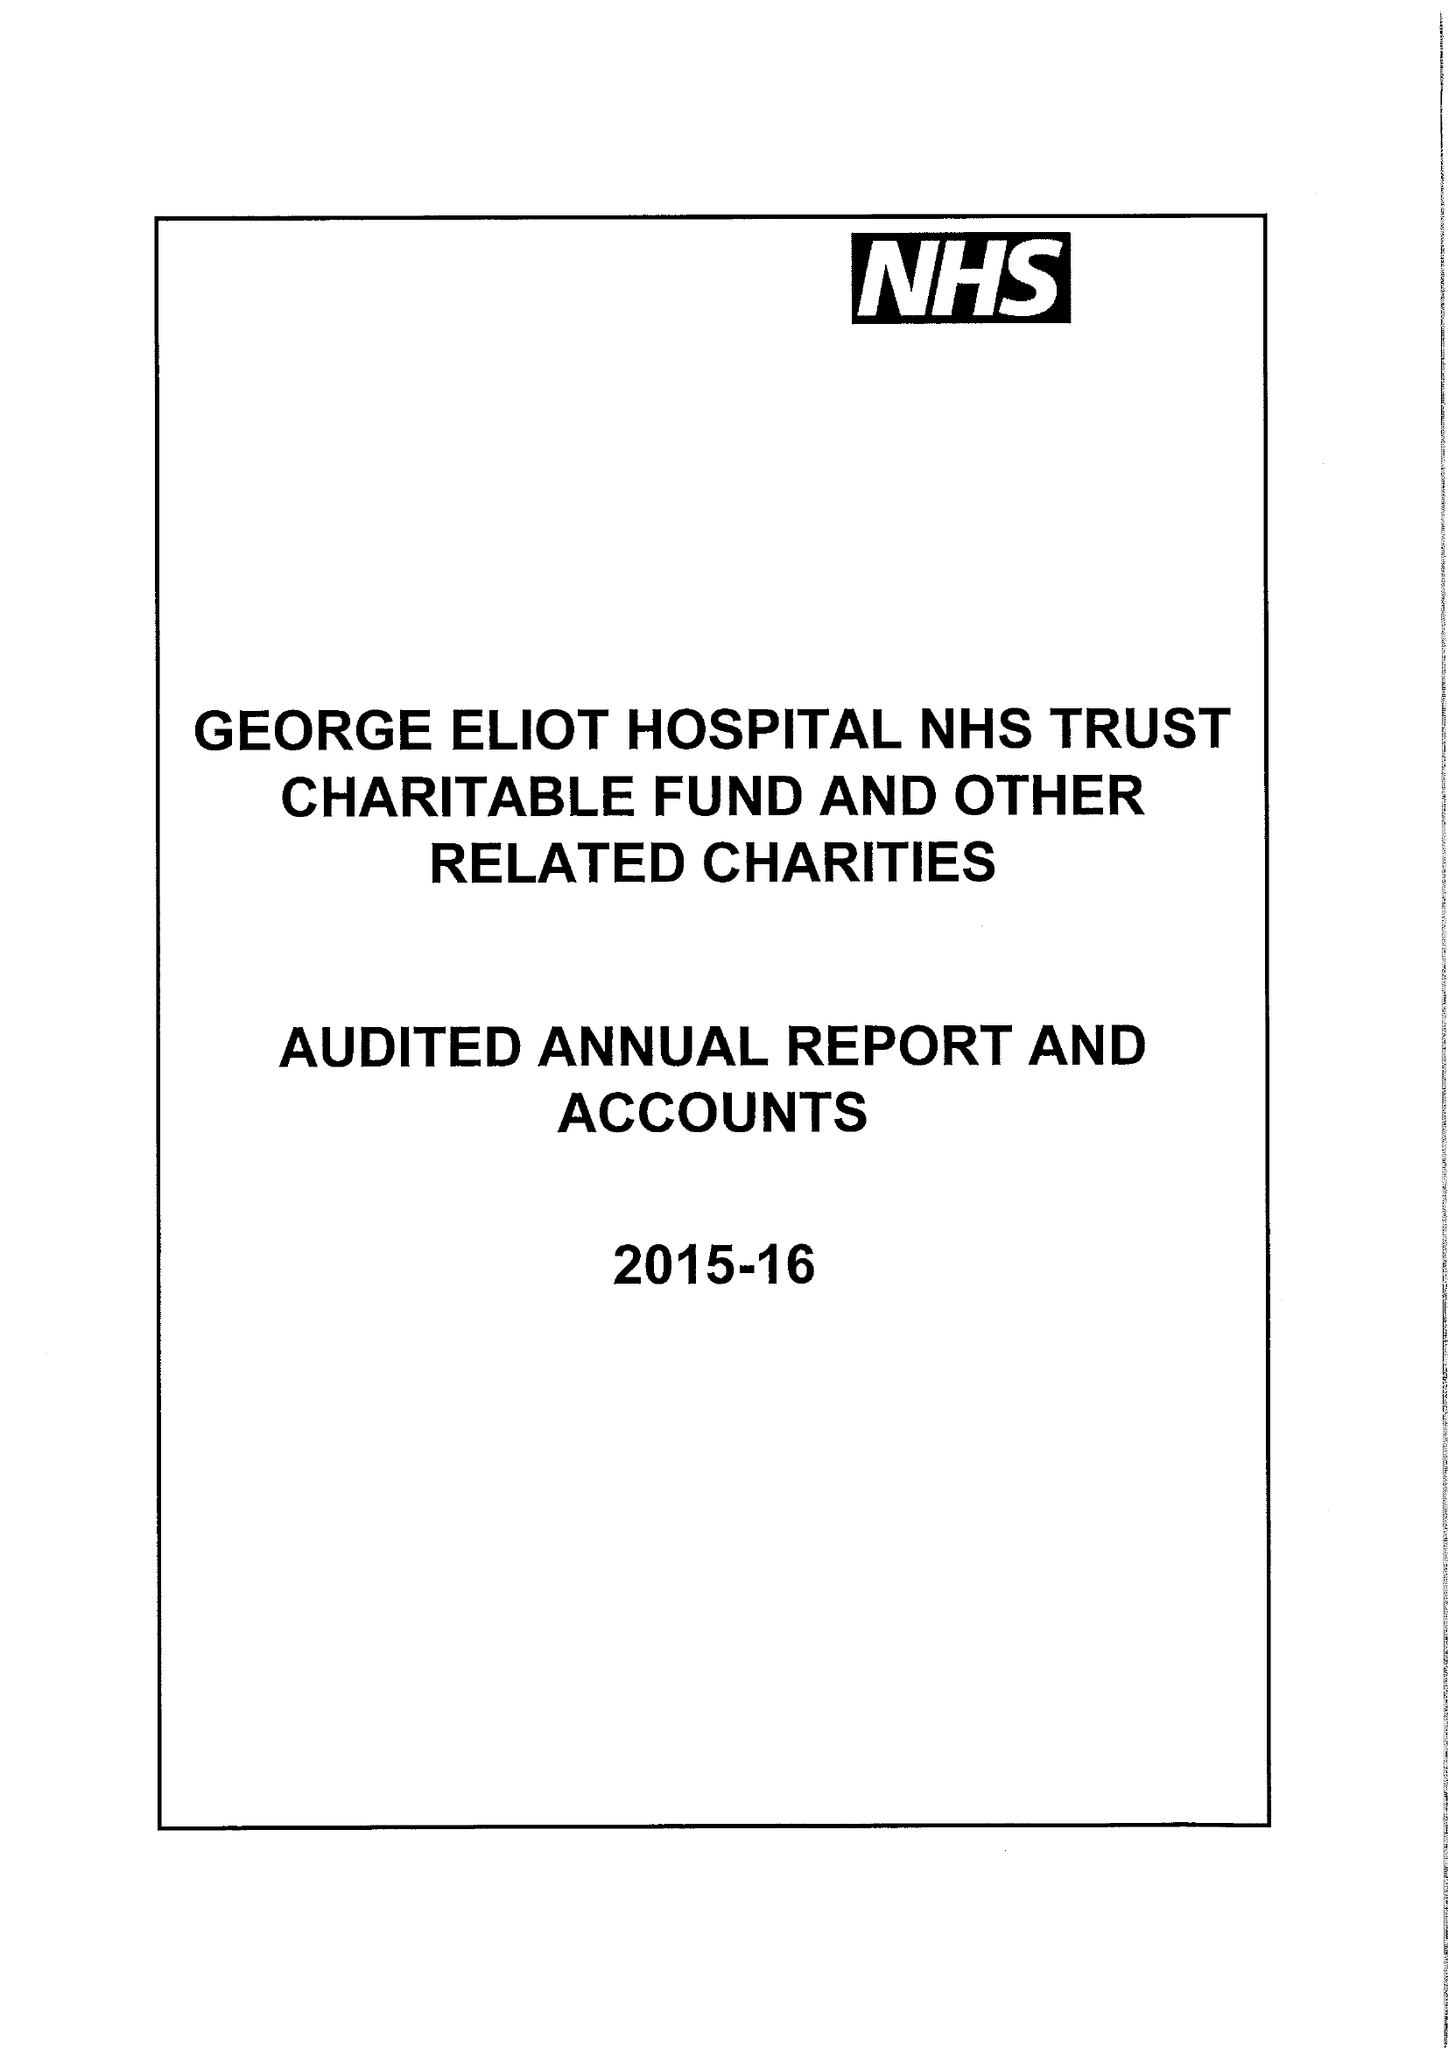What is the value for the address__postcode?
Answer the question using a single word or phrase. CV10 7DJ 